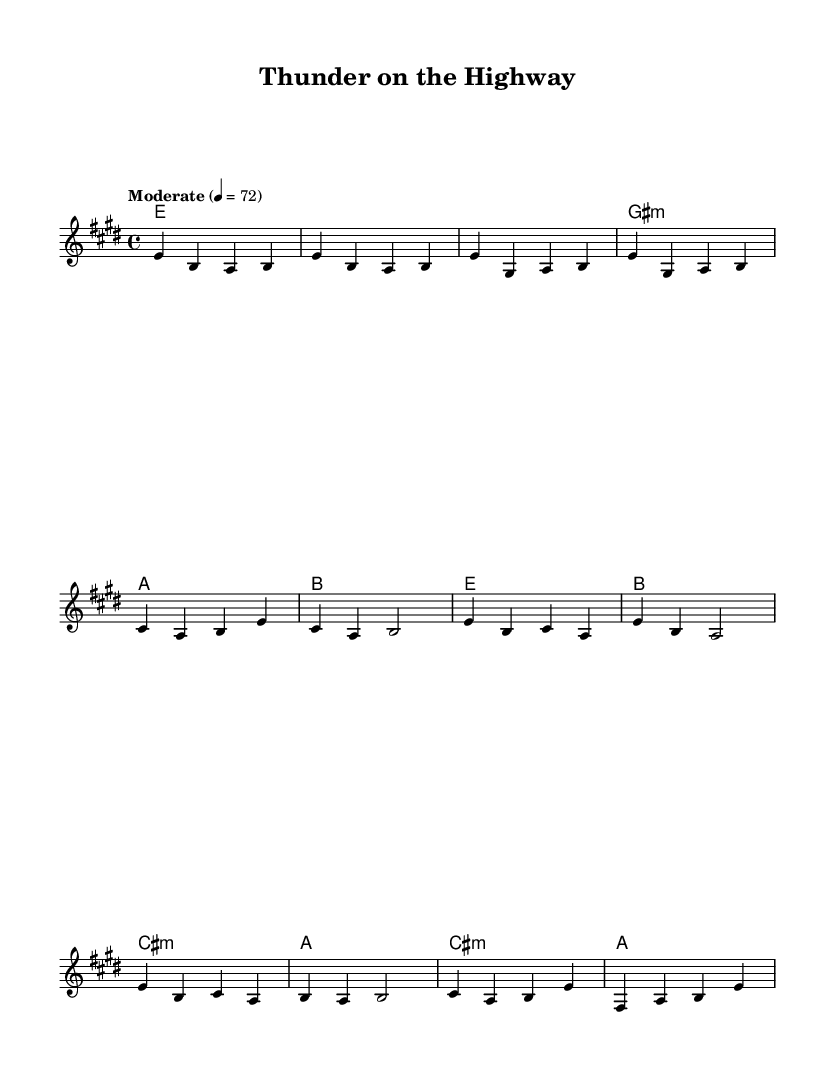What is the key signature of this music? The key signature is indicated by the sharps or flats at the beginning of the staff. In this case, there is four sharps, indicating it is in E major.
Answer: E major What is the time signature of this music? The time signature is shown at the beginning of the piece, represented by the numbers above the staff. Here, it shows 4 over 4, meaning four beats per measure in common time.
Answer: 4/4 What is the tempo marking of this piece? The tempo is given as a textual indication near the beginning, specifying the speed at which the piece should be played. The marking here reads "Moderate" with a metronome mark of 72 beats per minute.
Answer: Moderate, 72 How many measures are there in the provided melody? To find the total number of measures, count each measure bar line in the melody section. The provided melody has a total of 10 measures, as each measure is separated by a vertical line.
Answer: 10 What type of song structure does this music exhibit? The music shows a common structure reflective of classic rock ballads, featuring verses that tell a story, repetitive choruses, and a bridge providing contrast. This structure is typically verse-chorus-verse-chorus-bridge-chorus.
Answer: Verse-chorus What chords are used in the verse section? By examining the chord names laid above the appropriate measures, we can see that the chords in the verse section include E major, G# minor, A major, and B major.
Answer: E major, G# minor, A major, B major Which part of the song does the melody represent? To identify the parts of the song represented by the melody, we can reference common song structures, the labeled sections, and the flow of the notes. The provided melody encapsulates the intro and the first verse, reflecting the opening narrative of a romantic journey.
Answer: Intro and Verse 1 